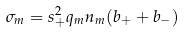<formula> <loc_0><loc_0><loc_500><loc_500>\sigma _ { m } = s _ { + } ^ { 2 } q _ { m } n _ { m } ( b _ { + } + b _ { - } )</formula> 